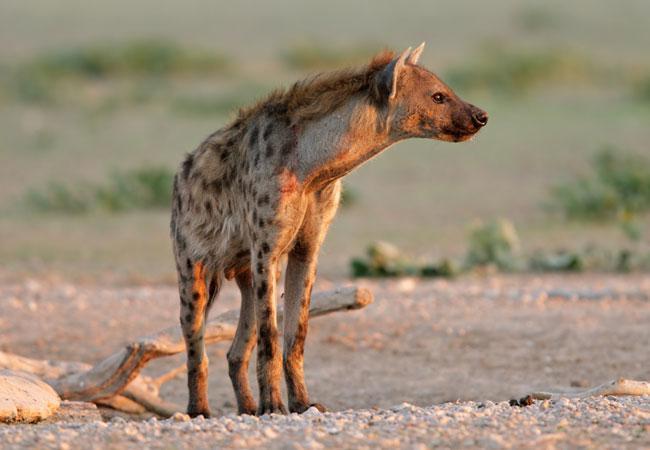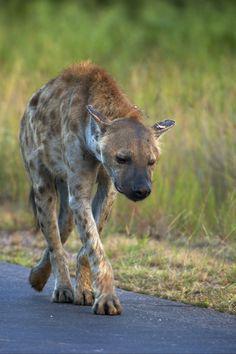The first image is the image on the left, the second image is the image on the right. For the images shown, is this caption "There is at least one animal carrying another animal or part of another animal." true? Answer yes or no. No. The first image is the image on the left, the second image is the image on the right. Evaluate the accuracy of this statement regarding the images: "There is a hyena carrying prey in its mouth.". Is it true? Answer yes or no. No. 